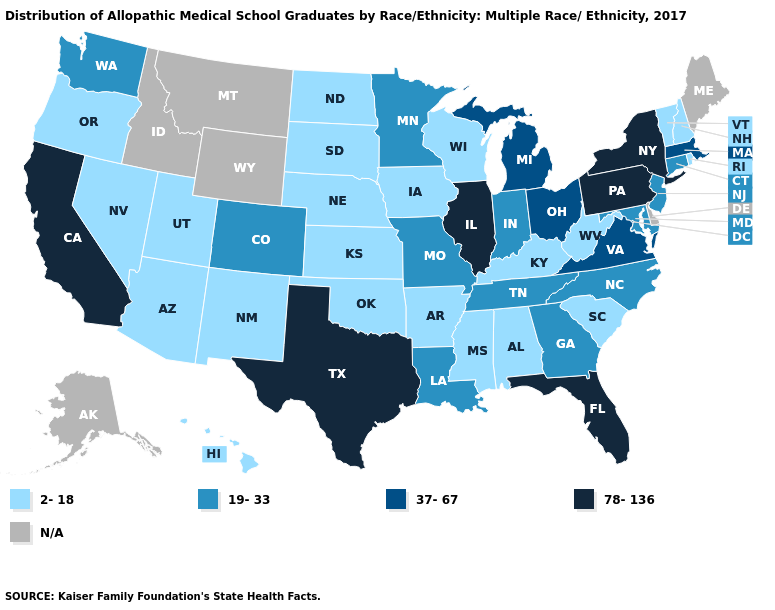What is the highest value in the USA?
Write a very short answer. 78-136. What is the highest value in states that border Maryland?
Concise answer only. 78-136. Which states have the lowest value in the USA?
Be succinct. Alabama, Arizona, Arkansas, Hawaii, Iowa, Kansas, Kentucky, Mississippi, Nebraska, Nevada, New Hampshire, New Mexico, North Dakota, Oklahoma, Oregon, Rhode Island, South Carolina, South Dakota, Utah, Vermont, West Virginia, Wisconsin. What is the value of Connecticut?
Short answer required. 19-33. Does the map have missing data?
Give a very brief answer. Yes. Name the states that have a value in the range 19-33?
Keep it brief. Colorado, Connecticut, Georgia, Indiana, Louisiana, Maryland, Minnesota, Missouri, New Jersey, North Carolina, Tennessee, Washington. Does Virginia have the lowest value in the USA?
Concise answer only. No. Does West Virginia have the lowest value in the USA?
Short answer required. Yes. What is the highest value in the USA?
Keep it brief. 78-136. Name the states that have a value in the range 19-33?
Be succinct. Colorado, Connecticut, Georgia, Indiana, Louisiana, Maryland, Minnesota, Missouri, New Jersey, North Carolina, Tennessee, Washington. Name the states that have a value in the range 19-33?
Short answer required. Colorado, Connecticut, Georgia, Indiana, Louisiana, Maryland, Minnesota, Missouri, New Jersey, North Carolina, Tennessee, Washington. Which states have the lowest value in the USA?
Answer briefly. Alabama, Arizona, Arkansas, Hawaii, Iowa, Kansas, Kentucky, Mississippi, Nebraska, Nevada, New Hampshire, New Mexico, North Dakota, Oklahoma, Oregon, Rhode Island, South Carolina, South Dakota, Utah, Vermont, West Virginia, Wisconsin. Name the states that have a value in the range 78-136?
Short answer required. California, Florida, Illinois, New York, Pennsylvania, Texas. Name the states that have a value in the range 2-18?
Concise answer only. Alabama, Arizona, Arkansas, Hawaii, Iowa, Kansas, Kentucky, Mississippi, Nebraska, Nevada, New Hampshire, New Mexico, North Dakota, Oklahoma, Oregon, Rhode Island, South Carolina, South Dakota, Utah, Vermont, West Virginia, Wisconsin. 